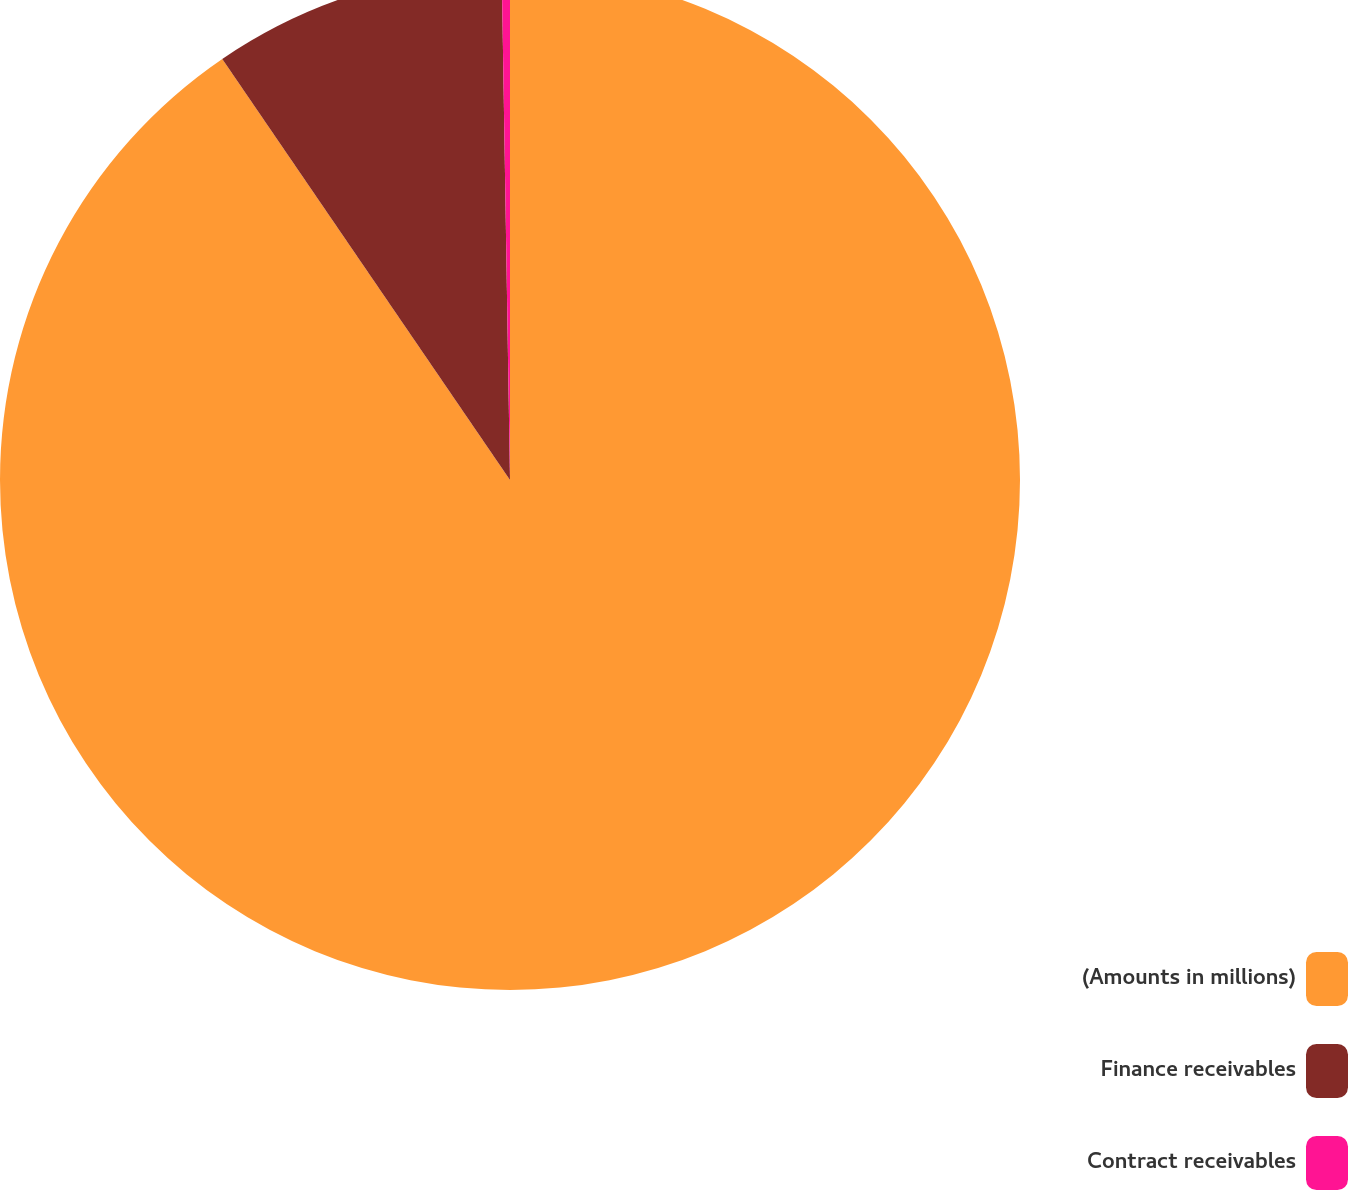Convert chart to OTSL. <chart><loc_0><loc_0><loc_500><loc_500><pie_chart><fcel>(Amounts in millions)<fcel>Finance receivables<fcel>Contract receivables<nl><fcel>90.46%<fcel>9.28%<fcel>0.26%<nl></chart> 